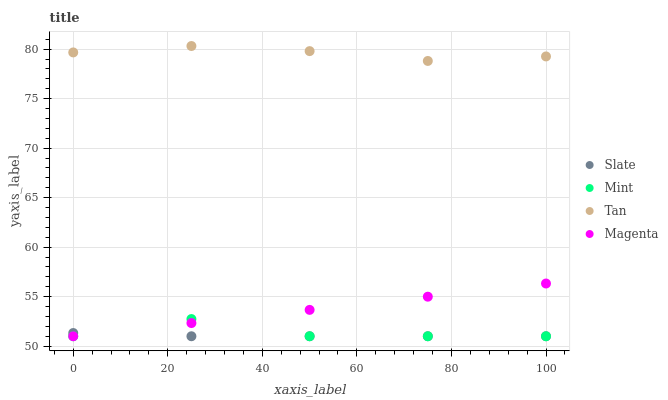Does Slate have the minimum area under the curve?
Answer yes or no. Yes. Does Tan have the maximum area under the curve?
Answer yes or no. Yes. Does Mint have the minimum area under the curve?
Answer yes or no. No. Does Mint have the maximum area under the curve?
Answer yes or no. No. Is Magenta the smoothest?
Answer yes or no. Yes. Is Mint the roughest?
Answer yes or no. Yes. Is Tan the smoothest?
Answer yes or no. No. Is Tan the roughest?
Answer yes or no. No. Does Slate have the lowest value?
Answer yes or no. Yes. Does Tan have the lowest value?
Answer yes or no. No. Does Tan have the highest value?
Answer yes or no. Yes. Does Mint have the highest value?
Answer yes or no. No. Is Mint less than Tan?
Answer yes or no. Yes. Is Tan greater than Slate?
Answer yes or no. Yes. Does Mint intersect Slate?
Answer yes or no. Yes. Is Mint less than Slate?
Answer yes or no. No. Is Mint greater than Slate?
Answer yes or no. No. Does Mint intersect Tan?
Answer yes or no. No. 